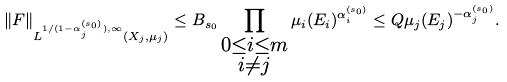<formula> <loc_0><loc_0><loc_500><loc_500>\| F \| _ { L ^ { 1 / ( 1 - \alpha ^ { ( s _ { 0 } ) } _ { j } ) , \infty } ( X _ { j } , \mu _ { j } ) } \leq B _ { s _ { 0 } } \prod _ { \substack { 0 \leq i \leq m \\ i \neq j } } \mu _ { i } ( E _ { i } ) ^ { \alpha ^ { ( s _ { 0 } ) } _ { i } } \leq Q \mu _ { j } ( E _ { j } ) ^ { - \alpha ^ { ( s _ { 0 } ) } _ { j } } .</formula> 